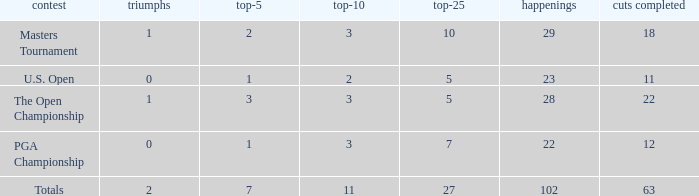How many vuts made for a player with 2 wins and under 7 top 5s? None. 